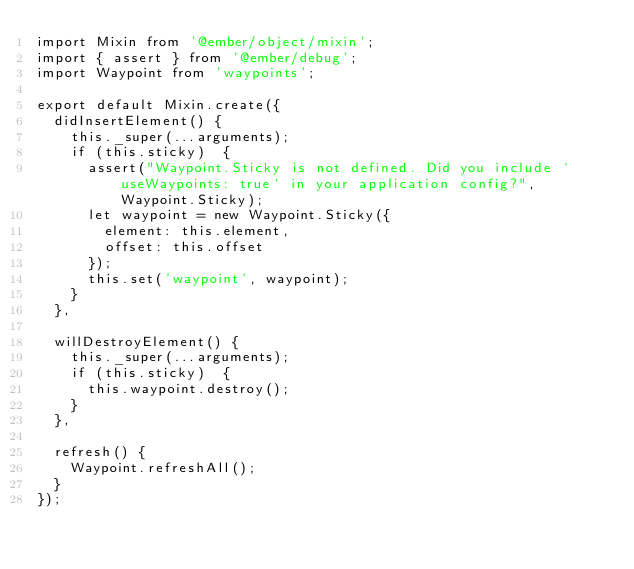Convert code to text. <code><loc_0><loc_0><loc_500><loc_500><_JavaScript_>import Mixin from '@ember/object/mixin';
import { assert } from '@ember/debug';
import Waypoint from 'waypoints';

export default Mixin.create({
  didInsertElement() {
    this._super(...arguments);
    if (this.sticky)  {
      assert("Waypoint.Sticky is not defined. Did you include `useWaypoints: true` in your application config?", Waypoint.Sticky);
      let waypoint = new Waypoint.Sticky({
        element: this.element,
        offset: this.offset
      });
      this.set('waypoint', waypoint);
    }
  },
  
  willDestroyElement() {
    this._super(...arguments);
    if (this.sticky)  {
      this.waypoint.destroy();
    }
  },
  
  refresh() {
    Waypoint.refreshAll();
  }
});
</code> 